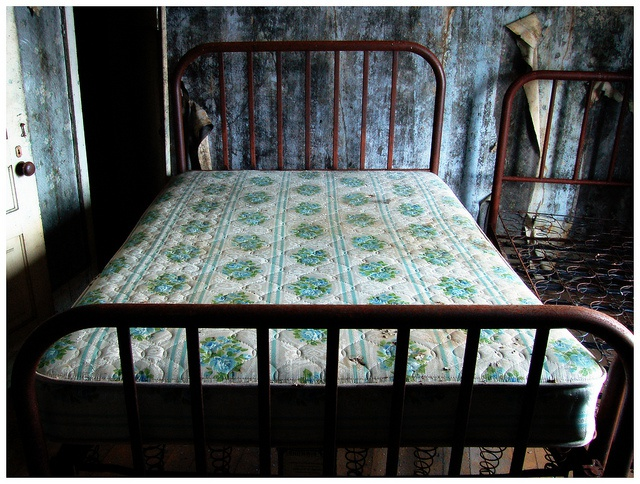Describe the objects in this image and their specific colors. I can see a bed in white, black, darkgray, gray, and lightgray tones in this image. 